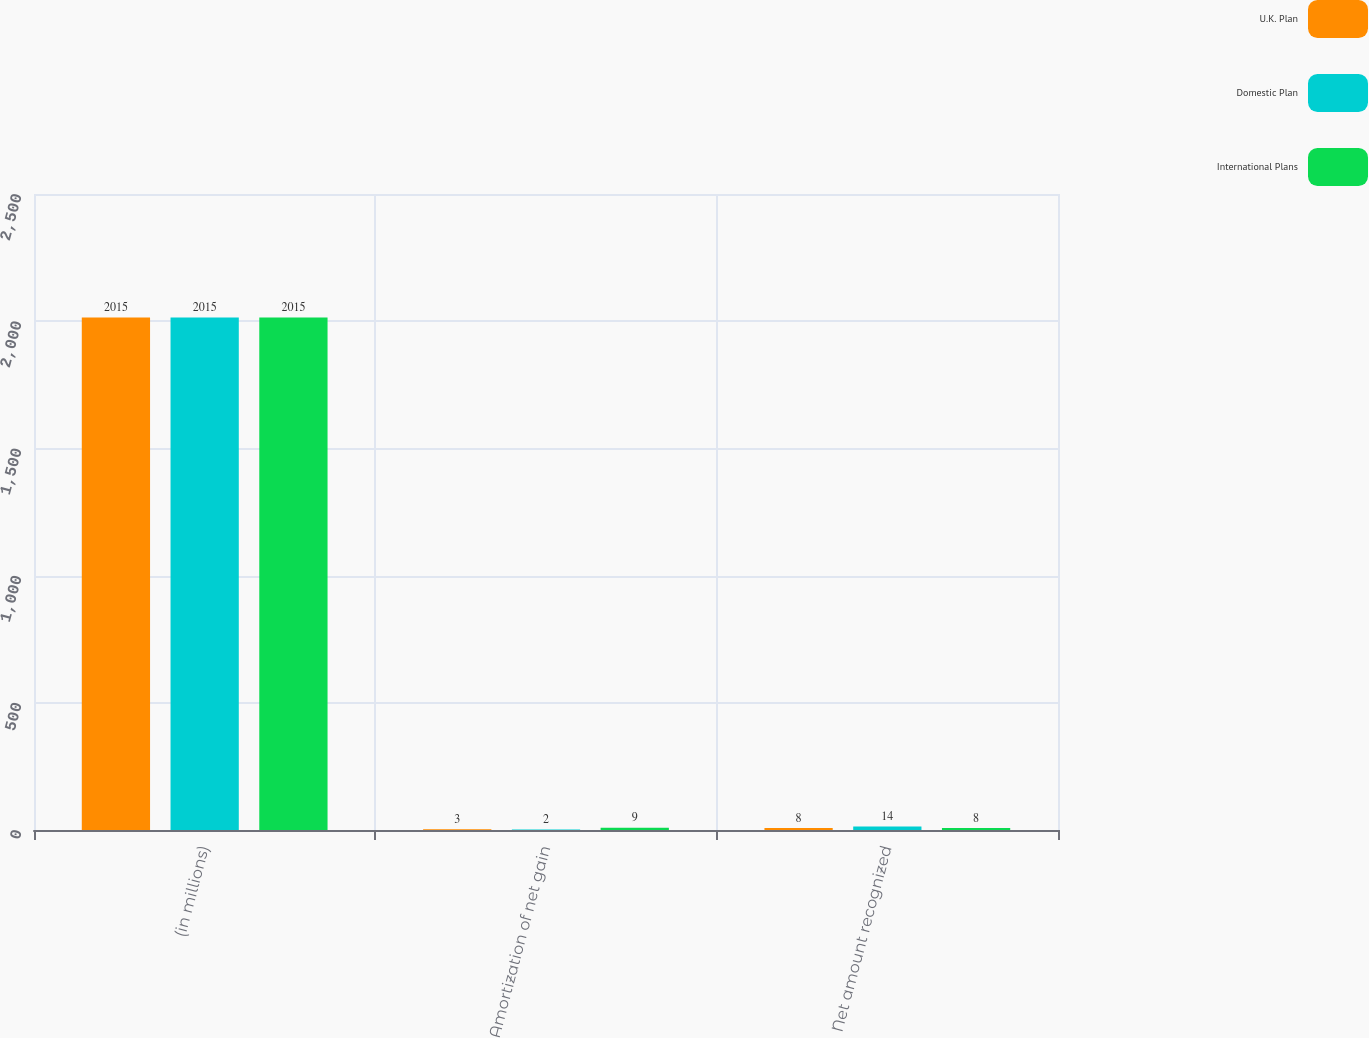<chart> <loc_0><loc_0><loc_500><loc_500><stacked_bar_chart><ecel><fcel>(in millions)<fcel>Amortization of net gain<fcel>Net amount recognized<nl><fcel>U.K. Plan<fcel>2015<fcel>3<fcel>8<nl><fcel>Domestic Plan<fcel>2015<fcel>2<fcel>14<nl><fcel>International Plans<fcel>2015<fcel>9<fcel>8<nl></chart> 